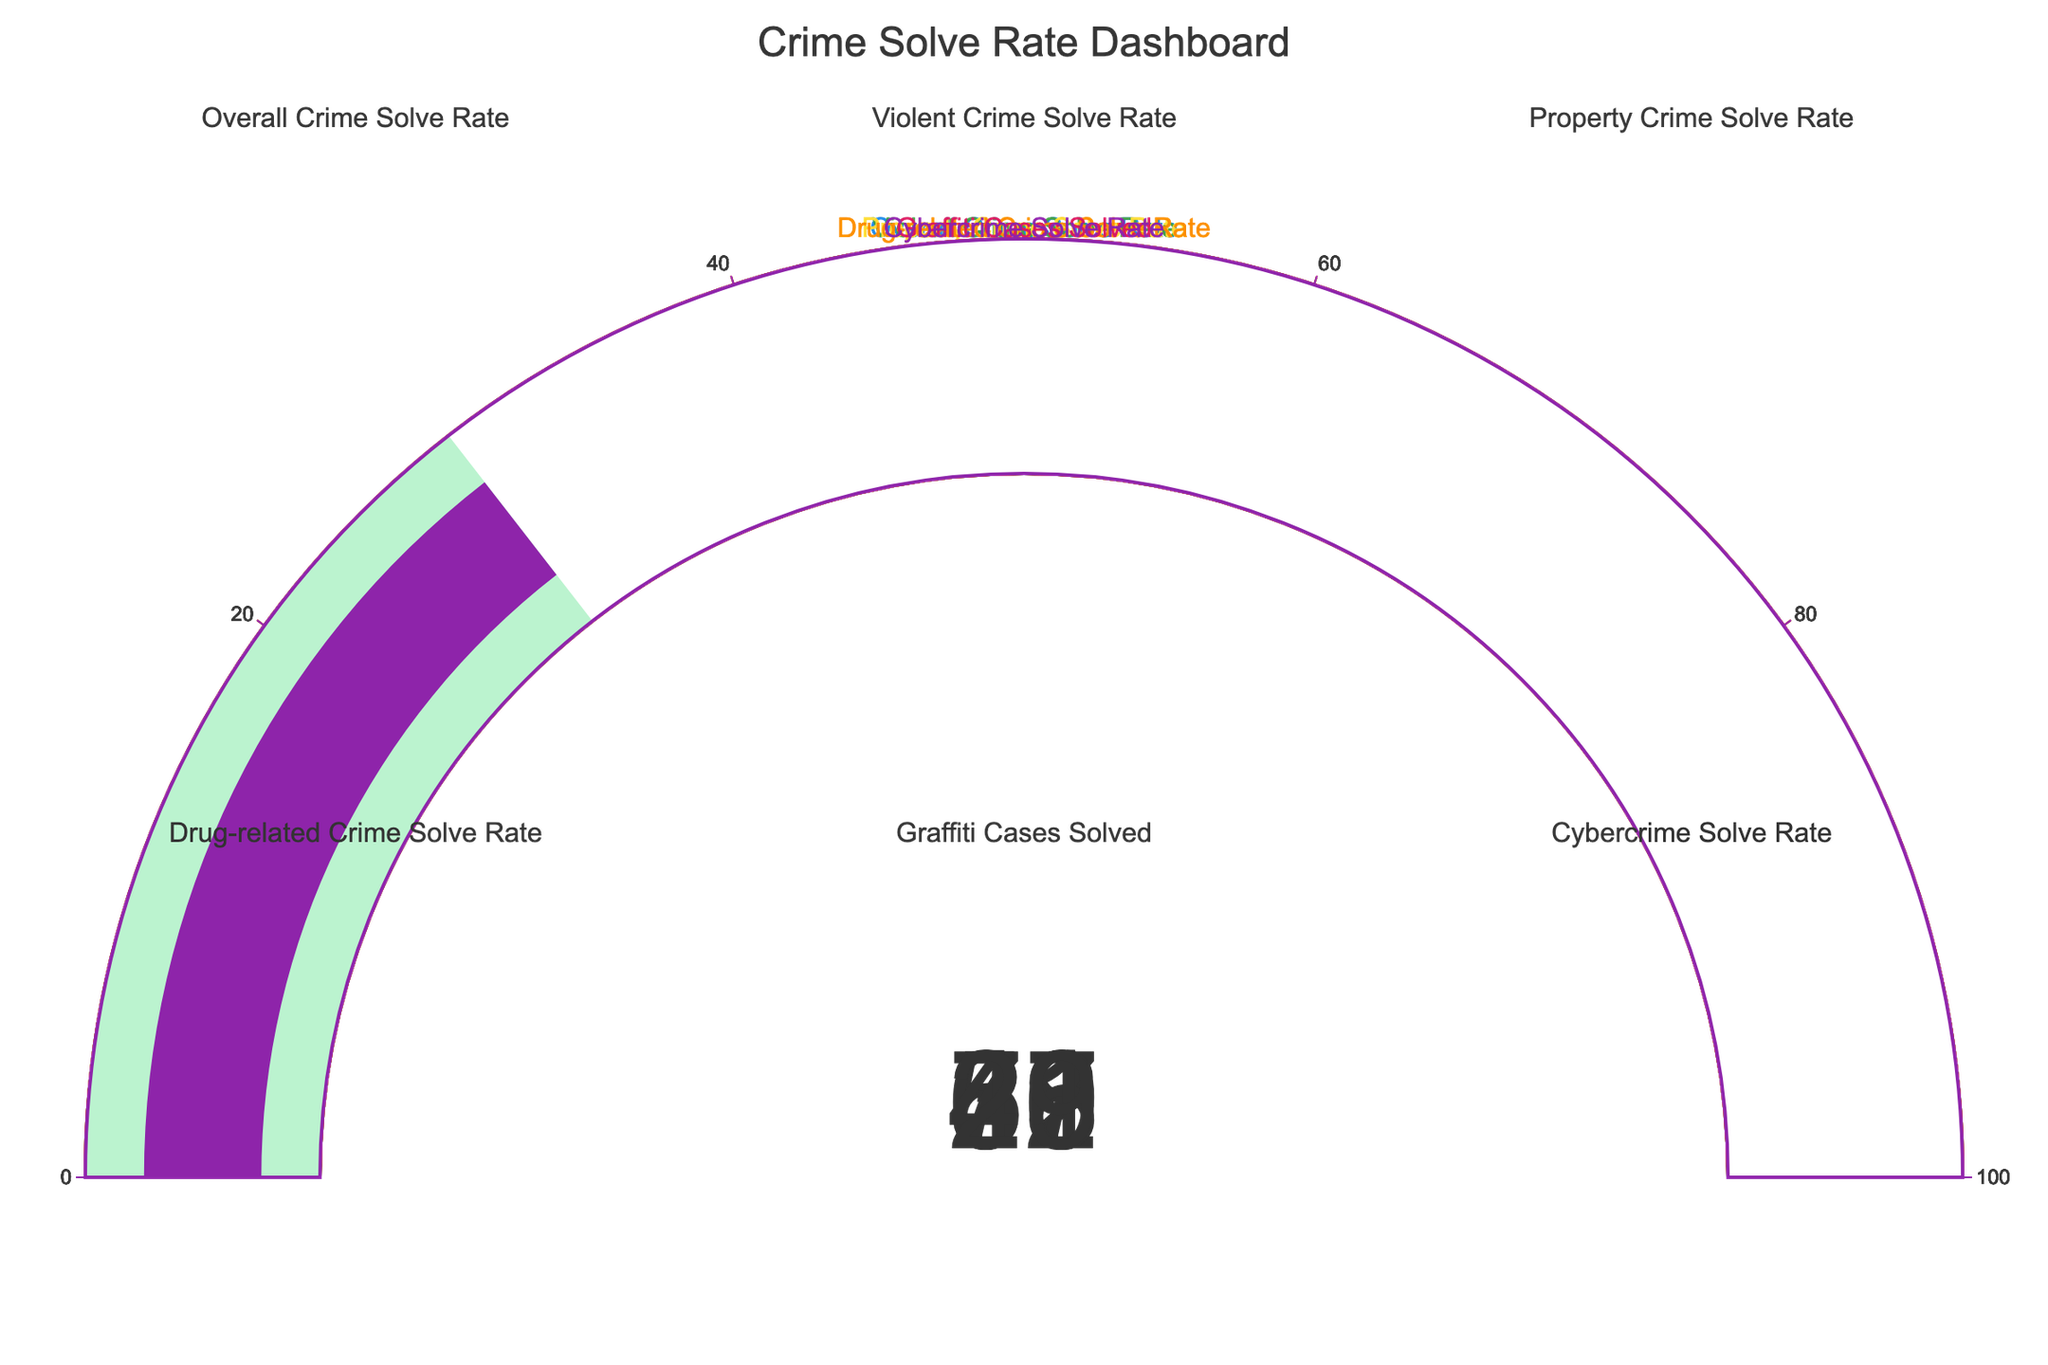What's the overall crime solve rate? The "Overall Crime Solve Rate" gauge shows the value of 52.
Answer: 52 Which category has the highest crime solve rate? Comparing all the gauge values, the highest number is found on the "Drug-related Crime Solve Rate" gauge, which is 76.
Answer: Drug-related Crime Solve Rate How much higher is the solve rate of violent crimes compared to property crimes? The violent crime solve rate is 68, and the property crime solve rate is 37. The difference is calculated as 68 - 37.
Answer: 31 What's the average solve rate across all crime categories? Sum all values: 52 (Overall) + 68 (Violent) + 37 (Property) + 76 (Drug-related) + 41 (Graffiti) + 29 (Cybercrime) = 303. There are 6 categories, so average is 303 / 6.
Answer: 50.5 Which crime category has the lowest solve rate? Comparing all gauges, the lowest value is on the "Cybercrime Solve Rate" gauge, which is 29.
Answer: Cybercrime Solve Rate How does the graffiti cases solve rate compare to the violent crime solve rate? The graffiti solve rate is 41, while the violent crime solve rate is 68. Comparing these values, 41 < 68.
Answer: Graffiti solve rate is lower What's the median solve rate of all categories? List all values in ascending order: 29, 37, 41, 52, 68, 76. With 6 values, the median is the average of the 3rd and 4th: (41 + 52) / 2.
Answer: 46.5 What's the range of solve rates across all categories? The range is the difference between the highest and lowest values. The highest is 76 (Drug-related Crime Solve Rate) and the lowest is 29 (Cybercrime Solve Rate), so the range is 76 - 29.
Answer: 47 